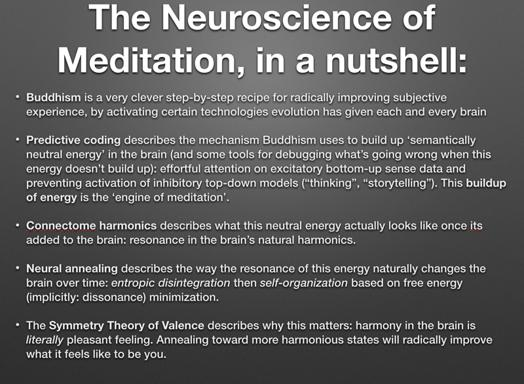What is the main topic discussed in the text? The primary subject of the text is an examination of the neuroscience underlying meditation practices, specifically looking at how these practices can fundamentally enhance brain function and subjective experience through well-defined neuroscientific frameworks. 